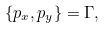<formula> <loc_0><loc_0><loc_500><loc_500>\{ p _ { x } , p _ { y } \} = \Gamma ,</formula> 